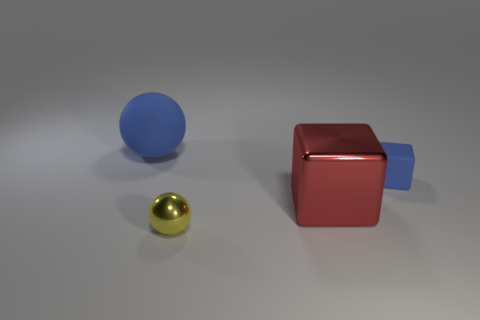What number of other tiny metallic things are the same shape as the small blue thing?
Provide a succinct answer. 0. How many big red metal objects are to the right of the blue thing on the left side of the matte block?
Keep it short and to the point. 1. How many rubber things are either large cubes or large gray spheres?
Make the answer very short. 0. Are there any red cylinders that have the same material as the big block?
Provide a succinct answer. No. How many objects are cubes that are right of the red cube or things that are on the left side of the large red shiny block?
Provide a short and direct response. 3. There is a rubber object to the right of the small yellow object; does it have the same color as the rubber sphere?
Your response must be concise. Yes. How many other objects are there of the same color as the small shiny object?
Offer a terse response. 0. What is the material of the large blue ball?
Provide a succinct answer. Rubber. There is a thing behind the blue matte block; is it the same size as the small ball?
Provide a short and direct response. No. Is there any other thing that has the same size as the blue block?
Make the answer very short. Yes. 